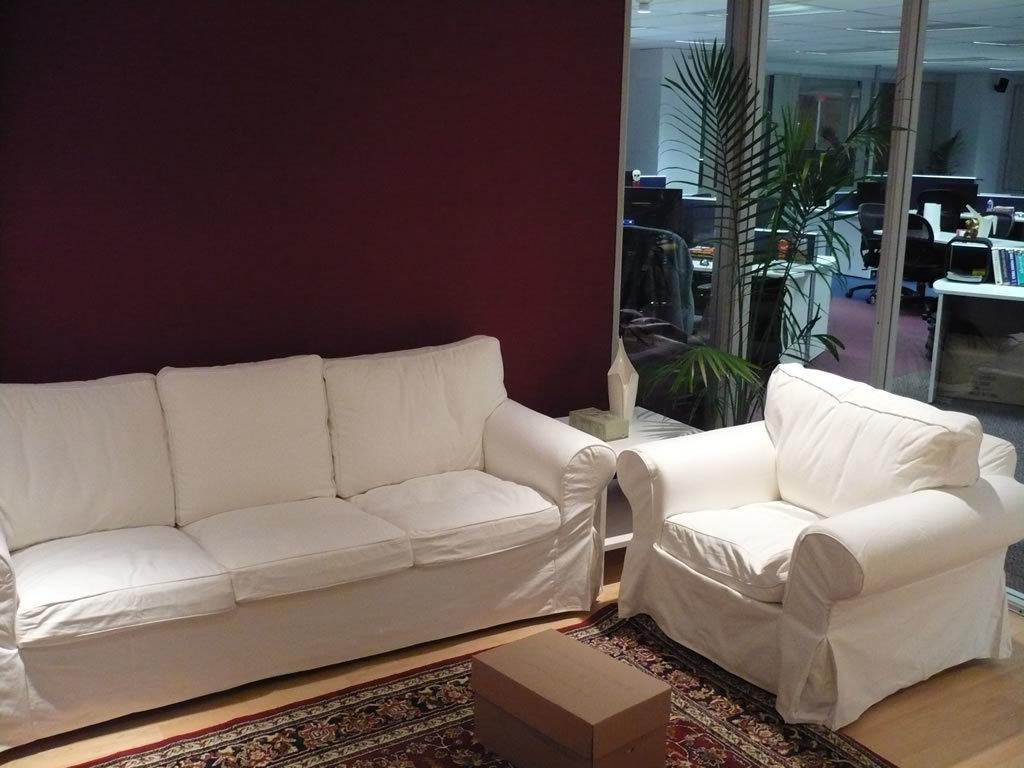What type of furniture is present in the image? There is a sofa couch, a table, and chairs in the image. What is on the floor in the image? There is a table on the floor in the image. What type of vegetation is present in the image? There is a plant in the image. How many tables are visible in the image? There are two tables visible in the image. What color is the sweater worn by the plant in the image? There is no sweater present in the image, as the plant is a non-living object and does not wear clothing. 